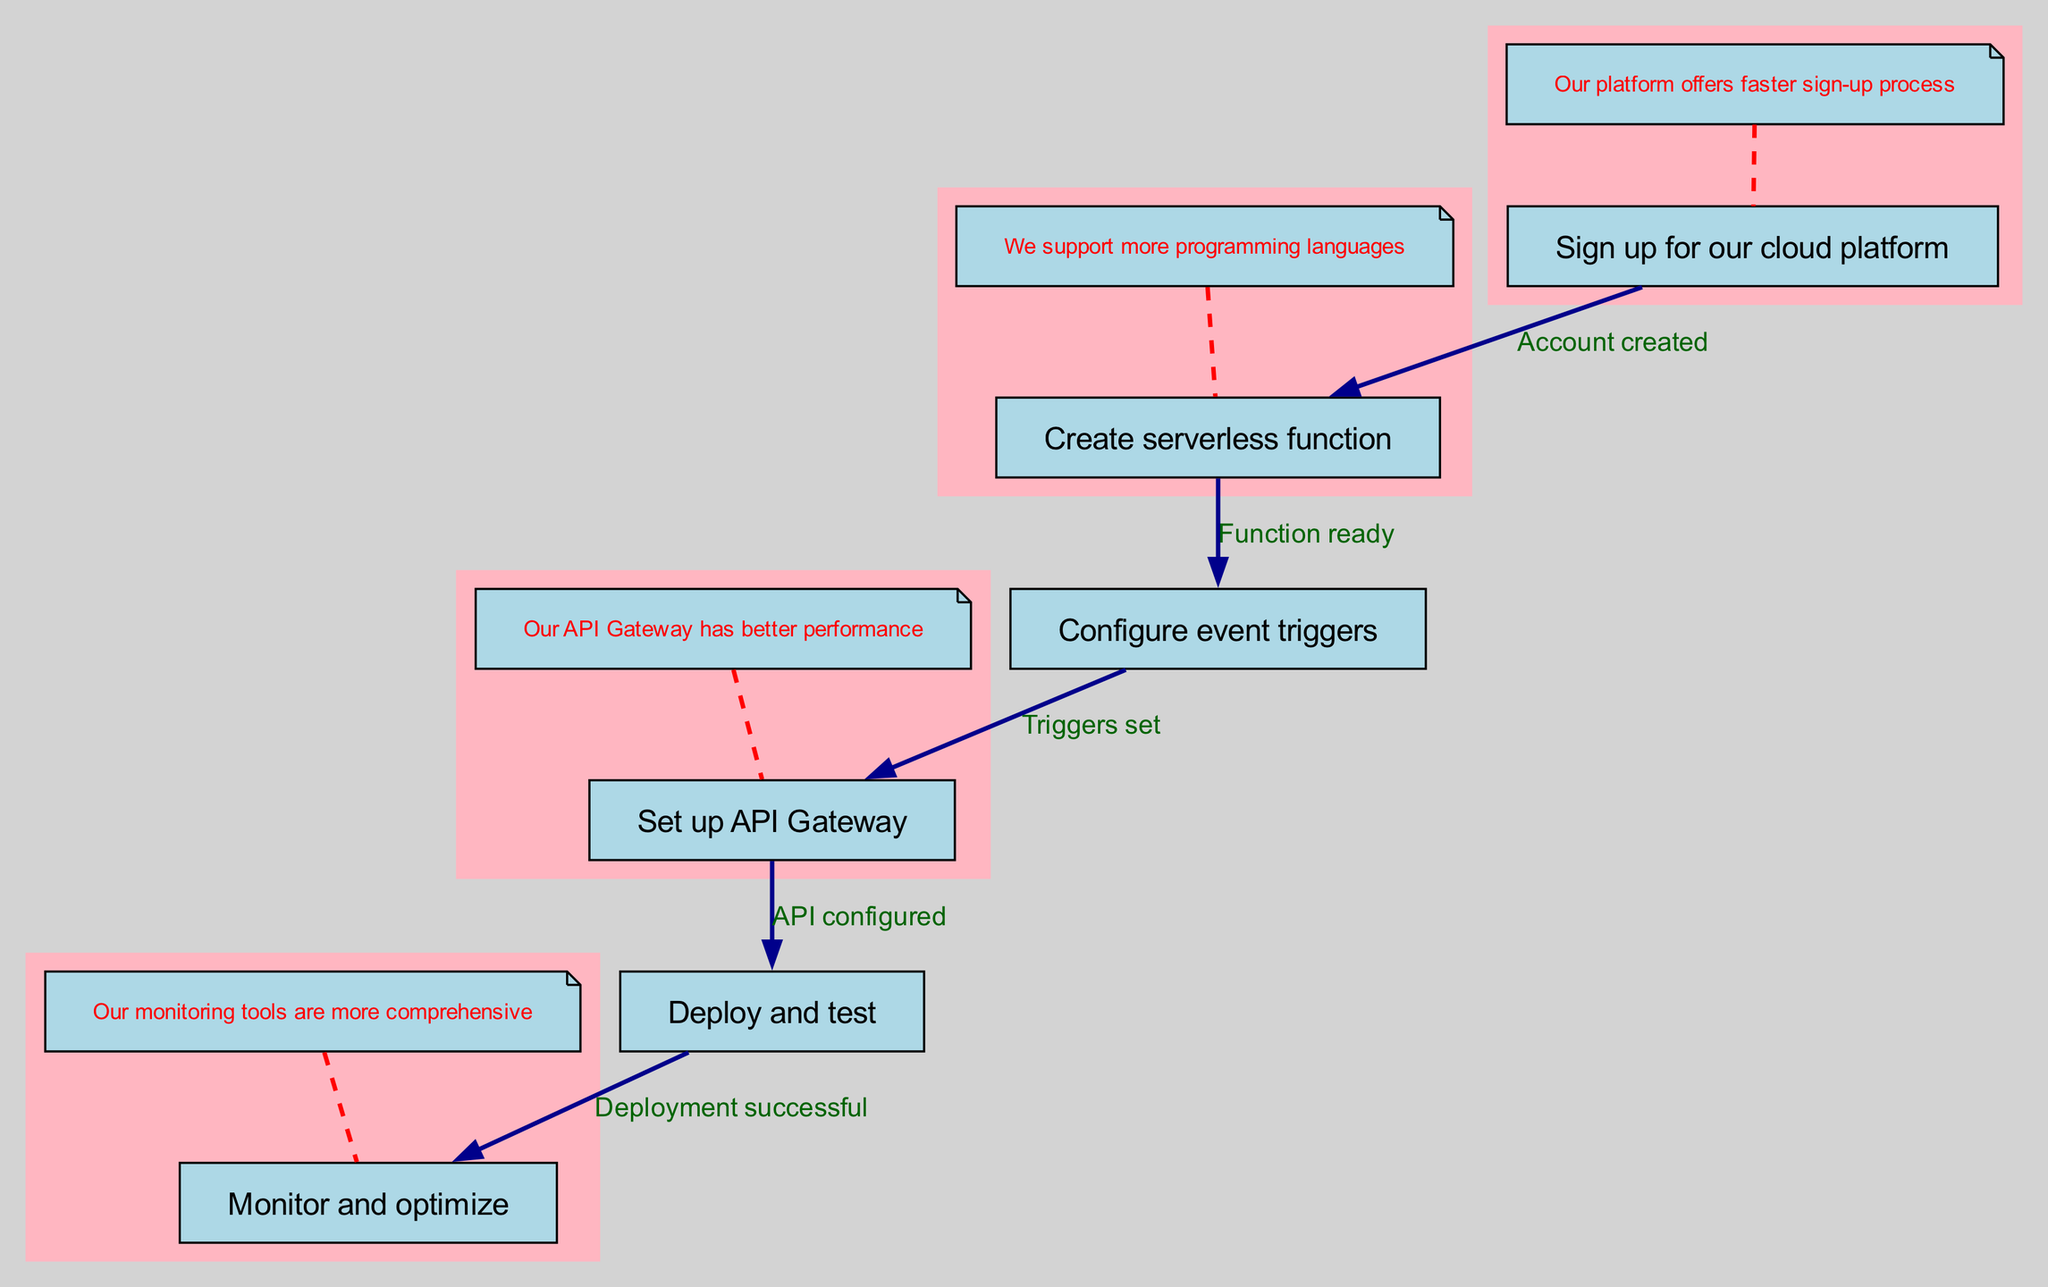What is the first step in the workflow? The workflow begins with the first node labeled "Sign up for our cloud platform." This node is the starting point of the entire process.
Answer: Sign up for our cloud platform How many nodes are in the diagram? The diagram contains a total of six nodes, each representing a distinct step in the serverless architecture implementation workflow.
Answer: 6 What is the relationship between the "Create serverless function" and "Configure event triggers" nodes? The "Create serverless function" node connects to the "Configure event triggers" node with the label "Function ready." This indicates that the function is prepared before configuring event triggers.
Answer: Function ready What occurs after the "Set up API Gateway"? After "Set up API Gateway," the next step outlined in the workflow is "Deploy and test," signifying the direct progression from API configuration to deployment.
Answer: Deploy and test Which comment pertains to the API Gateway? The comment associated with the API Gateway states, "Our API Gateway has better performance," providing additional context about this step in the workflow.
Answer: Our API Gateway has better performance What is the final step in the workflow? The last node in the workflow is "Monitor and optimize," which follows after successful deployment in the serverless architecture implementation process.
Answer: Monitor and optimize How does one move from "Deploy and test" to "Monitor and optimize"? One transitions from "Deploy and test" to "Monitor and optimize" based on the successful deployment indicated by the edge labeled "Deployment successful," connecting these two steps.
Answer: Deployment successful What is the third step in the workflow? The third step of the workflow is "Configure event triggers," which follows the "Create serverless function" step, as indicated in the flow chart.
Answer: Configure event triggers What type of cloud service does this workflow represent? This workflow illustrates the process of implementing serverless architecture, specifically tailored for users of the showcased cloud platform.
Answer: Serverless architecture 